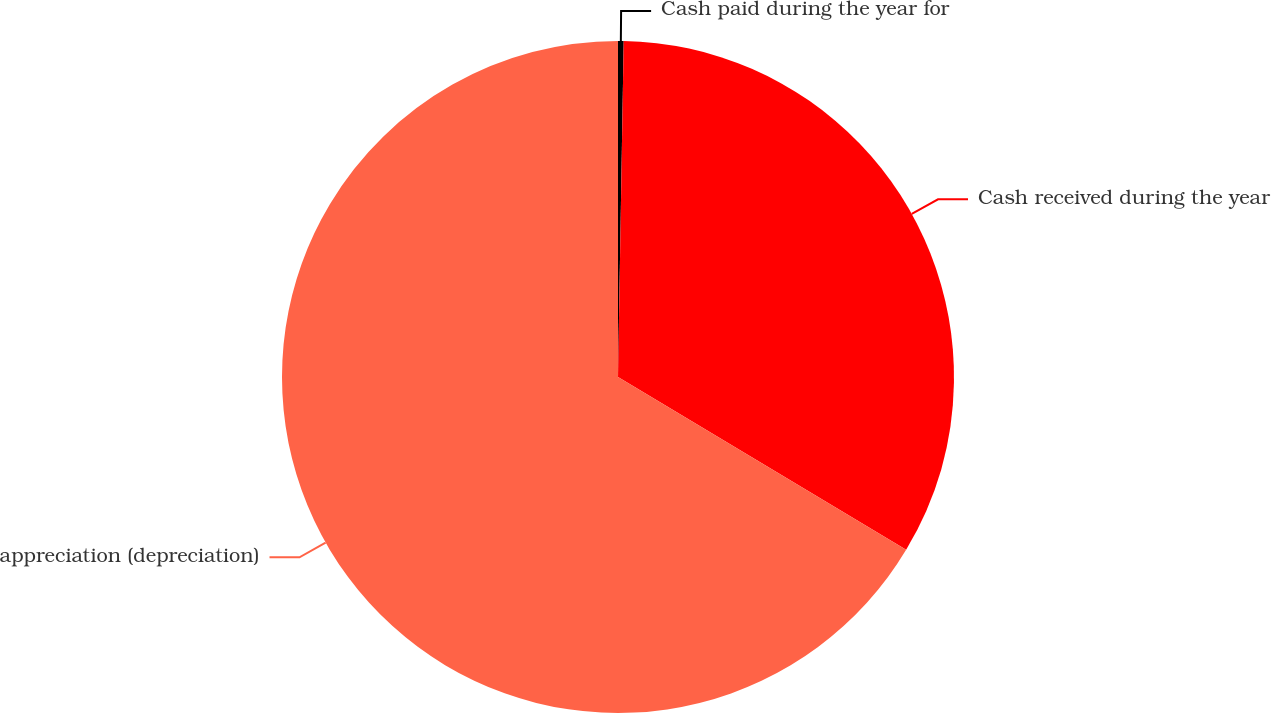Convert chart. <chart><loc_0><loc_0><loc_500><loc_500><pie_chart><fcel>Cash paid during the year for<fcel>Cash received during the year<fcel>appreciation (depreciation)<nl><fcel>0.27%<fcel>33.33%<fcel>66.4%<nl></chart> 